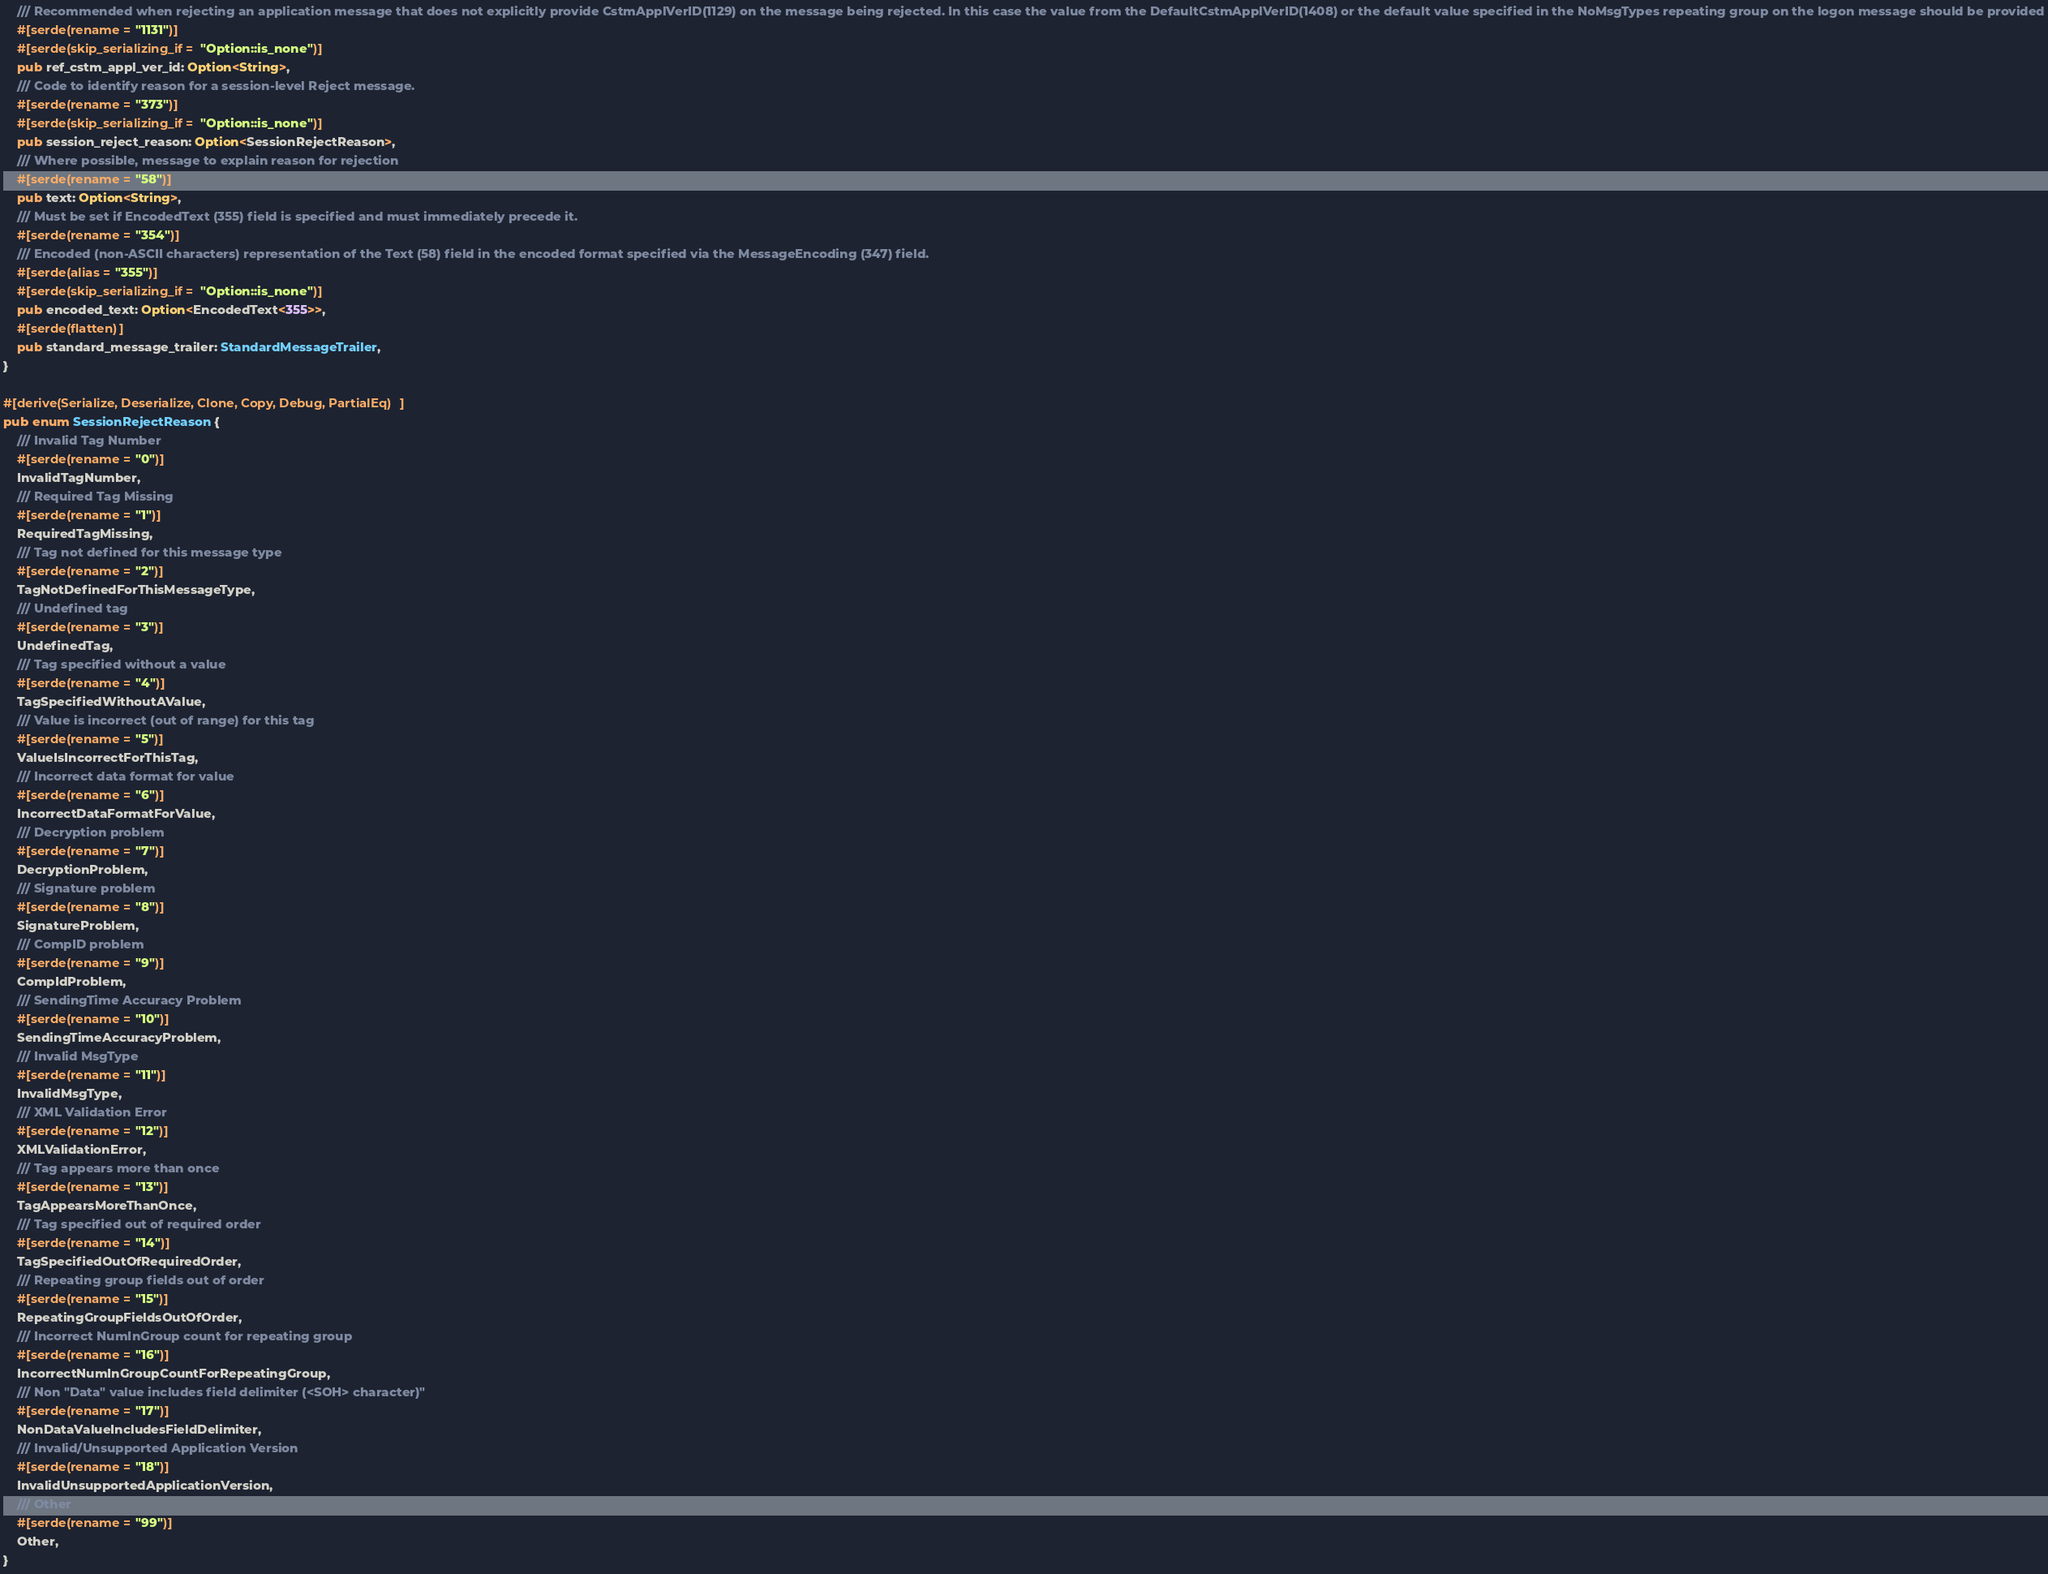Convert code to text. <code><loc_0><loc_0><loc_500><loc_500><_Rust_>    /// Recommended when rejecting an application message that does not explicitly provide CstmApplVerID(1129) on the message being rejected. In this case the value from the DefaultCstmApplVerID(1408) or the default value specified in the NoMsgTypes repeating group on the logon message should be provided
    #[serde(rename = "1131")]
    #[serde(skip_serializing_if = "Option::is_none")]
    pub ref_cstm_appl_ver_id: Option<String>,
    /// Code to identify reason for a session-level Reject message.
    #[serde(rename = "373")]
    #[serde(skip_serializing_if = "Option::is_none")]
    pub session_reject_reason: Option<SessionRejectReason>,
    /// Where possible, message to explain reason for rejection
    #[serde(rename = "58")]
    pub text: Option<String>,
    /// Must be set if EncodedText (355) field is specified and must immediately precede it.
    #[serde(rename = "354")]
    /// Encoded (non-ASCII characters) representation of the Text (58) field in the encoded format specified via the MessageEncoding (347) field. 
    #[serde(alias = "355")]
    #[serde(skip_serializing_if = "Option::is_none")]
    pub encoded_text: Option<EncodedText<355>>,
    #[serde(flatten)]
    pub standard_message_trailer: StandardMessageTrailer,
}

#[derive(Serialize, Deserialize, Clone, Copy, Debug, PartialEq)]
pub enum SessionRejectReason {
    /// Invalid Tag Number
    #[serde(rename = "0")]
    InvalidTagNumber,
    /// Required Tag Missing
    #[serde(rename = "1")]
    RequiredTagMissing,
    /// Tag not defined for this message type
    #[serde(rename = "2")]
    TagNotDefinedForThisMessageType,
    /// Undefined tag
    #[serde(rename = "3")]
    UndefinedTag,
    /// Tag specified without a value
    #[serde(rename = "4")]
    TagSpecifiedWithoutAValue,
    /// Value is incorrect (out of range) for this tag
    #[serde(rename = "5")]
    ValueIsIncorrectForThisTag,
    /// Incorrect data format for value
    #[serde(rename = "6")]
    IncorrectDataFormatForValue,
    /// Decryption problem
    #[serde(rename = "7")]
    DecryptionProblem,
    /// Signature problem
    #[serde(rename = "8")]
    SignatureProblem,
    /// CompID problem
    #[serde(rename = "9")]
    CompIdProblem,
    /// SendingTime Accuracy Problem
    #[serde(rename = "10")]
    SendingTimeAccuracyProblem,
    /// Invalid MsgType
    #[serde(rename = "11")]
    InvalidMsgType,
    /// XML Validation Error
    #[serde(rename = "12")]
    XMLValidationError,
    /// Tag appears more than once
    #[serde(rename = "13")]
    TagAppearsMoreThanOnce,
    /// Tag specified out of required order
    #[serde(rename = "14")]
    TagSpecifiedOutOfRequiredOrder,
    /// Repeating group fields out of order
    #[serde(rename = "15")]
    RepeatingGroupFieldsOutOfOrder,
    /// Incorrect NumInGroup count for repeating group
    #[serde(rename = "16")]
    IncorrectNumInGroupCountForRepeatingGroup,
    /// Non "Data" value includes field delimiter (<SOH> character)"
    #[serde(rename = "17")]
    NonDataValueIncludesFieldDelimiter,
    /// Invalid/Unsupported Application Version
    #[serde(rename = "18")]
    InvalidUnsupportedApplicationVersion,
    /// Other
    #[serde(rename = "99")]
    Other,
}
</code> 